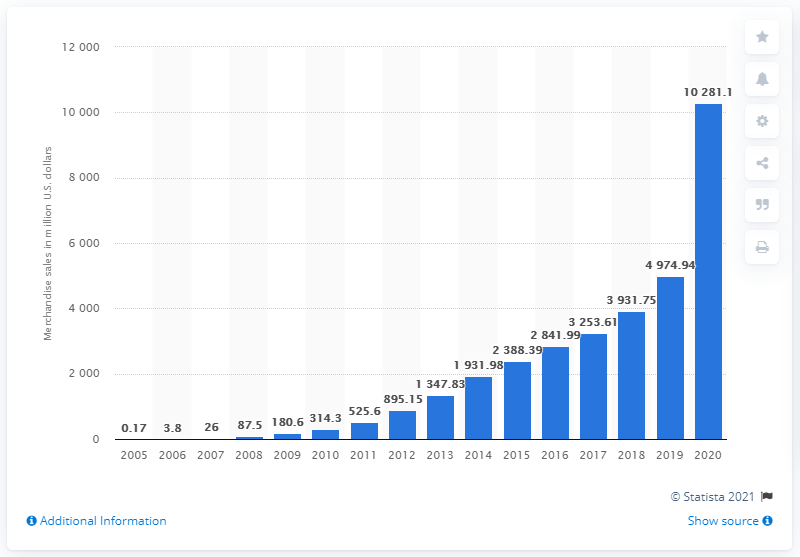Based on this data, what could be the potential sales for 2021? While the graph does not provide data beyond 2020, the strong upward trend and the massive increase in 2020 may suggest further growth in 2021. However, without additional data or considering external factors such as economic conditions and changes in consumer behavior, it would be speculative to provide a precise number for 2021 sales volumes. 